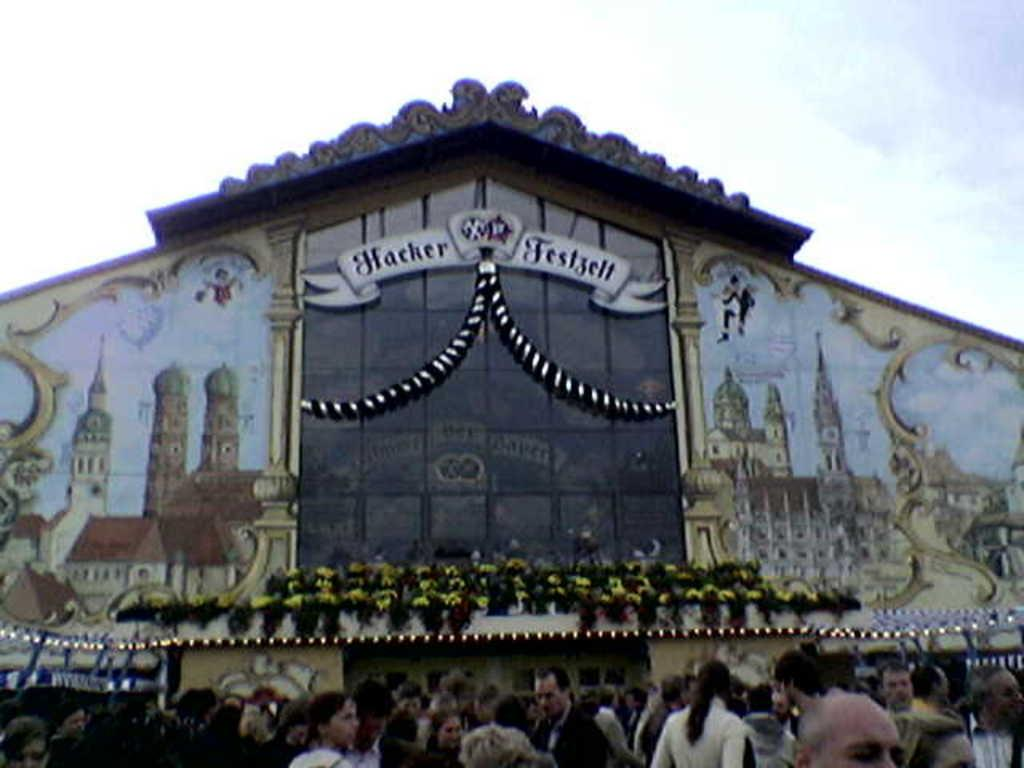<image>
Present a compact description of the photo's key features. the outside of an ornate building reading Hacker Festzelt 